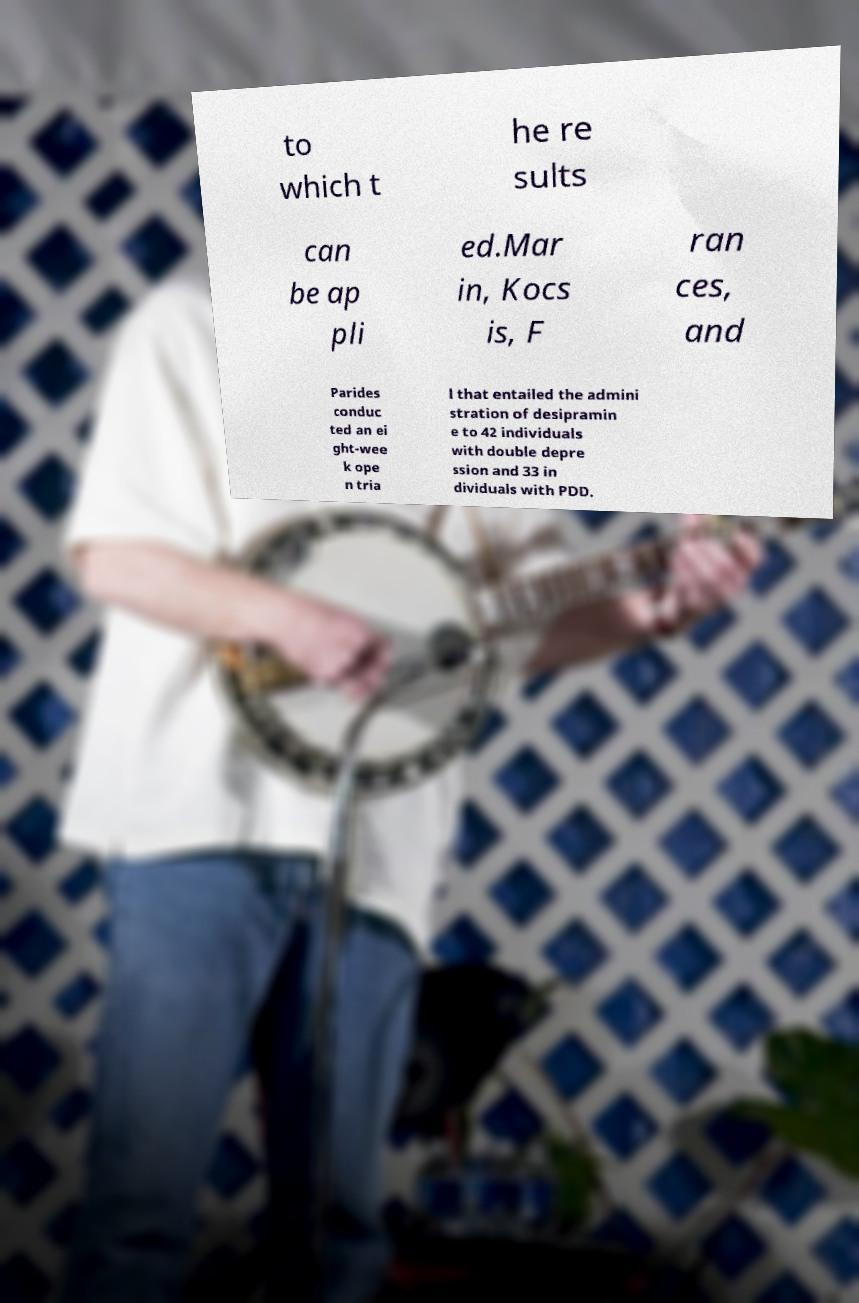Could you extract and type out the text from this image? to which t he re sults can be ap pli ed.Mar in, Kocs is, F ran ces, and Parides conduc ted an ei ght-wee k ope n tria l that entailed the admini stration of desipramin e to 42 individuals with double depre ssion and 33 in dividuals with PDD. 